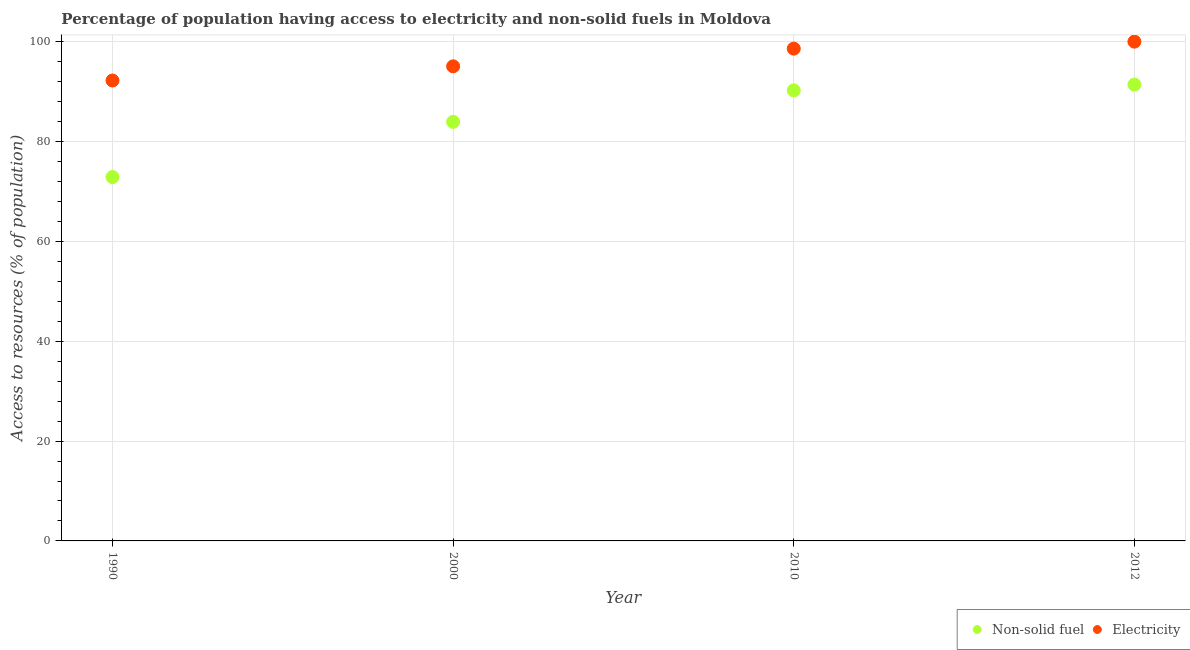How many different coloured dotlines are there?
Ensure brevity in your answer.  2. What is the percentage of population having access to electricity in 2010?
Make the answer very short. 98.6. Across all years, what is the maximum percentage of population having access to non-solid fuel?
Your answer should be very brief. 91.4. Across all years, what is the minimum percentage of population having access to electricity?
Your answer should be compact. 92.22. In which year was the percentage of population having access to non-solid fuel minimum?
Ensure brevity in your answer.  1990. What is the total percentage of population having access to electricity in the graph?
Your answer should be compact. 385.87. What is the difference between the percentage of population having access to electricity in 1990 and that in 2000?
Your answer should be compact. -2.84. What is the difference between the percentage of population having access to electricity in 2012 and the percentage of population having access to non-solid fuel in 2000?
Ensure brevity in your answer.  16.07. What is the average percentage of population having access to electricity per year?
Your answer should be very brief. 96.47. In the year 2012, what is the difference between the percentage of population having access to non-solid fuel and percentage of population having access to electricity?
Make the answer very short. -8.6. In how many years, is the percentage of population having access to electricity greater than 36 %?
Offer a terse response. 4. What is the ratio of the percentage of population having access to non-solid fuel in 1990 to that in 2010?
Offer a terse response. 0.81. Is the percentage of population having access to electricity in 2000 less than that in 2010?
Keep it short and to the point. Yes. What is the difference between the highest and the second highest percentage of population having access to electricity?
Your answer should be compact. 1.4. What is the difference between the highest and the lowest percentage of population having access to electricity?
Ensure brevity in your answer.  7.78. Is the sum of the percentage of population having access to electricity in 1990 and 2010 greater than the maximum percentage of population having access to non-solid fuel across all years?
Your answer should be very brief. Yes. Does the percentage of population having access to non-solid fuel monotonically increase over the years?
Give a very brief answer. Yes. Is the percentage of population having access to non-solid fuel strictly greater than the percentage of population having access to electricity over the years?
Provide a short and direct response. No. How many dotlines are there?
Provide a succinct answer. 2. How many years are there in the graph?
Make the answer very short. 4. Are the values on the major ticks of Y-axis written in scientific E-notation?
Make the answer very short. No. Where does the legend appear in the graph?
Offer a terse response. Bottom right. How many legend labels are there?
Offer a terse response. 2. What is the title of the graph?
Provide a short and direct response. Percentage of population having access to electricity and non-solid fuels in Moldova. What is the label or title of the X-axis?
Offer a terse response. Year. What is the label or title of the Y-axis?
Provide a succinct answer. Access to resources (% of population). What is the Access to resources (% of population) in Non-solid fuel in 1990?
Make the answer very short. 72.88. What is the Access to resources (% of population) of Electricity in 1990?
Provide a short and direct response. 92.22. What is the Access to resources (% of population) of Non-solid fuel in 2000?
Offer a very short reply. 83.93. What is the Access to resources (% of population) of Electricity in 2000?
Your answer should be compact. 95.06. What is the Access to resources (% of population) in Non-solid fuel in 2010?
Keep it short and to the point. 90.24. What is the Access to resources (% of population) of Electricity in 2010?
Give a very brief answer. 98.6. What is the Access to resources (% of population) in Non-solid fuel in 2012?
Your answer should be compact. 91.4. Across all years, what is the maximum Access to resources (% of population) in Non-solid fuel?
Ensure brevity in your answer.  91.4. Across all years, what is the maximum Access to resources (% of population) of Electricity?
Offer a terse response. 100. Across all years, what is the minimum Access to resources (% of population) in Non-solid fuel?
Ensure brevity in your answer.  72.88. Across all years, what is the minimum Access to resources (% of population) of Electricity?
Ensure brevity in your answer.  92.22. What is the total Access to resources (% of population) of Non-solid fuel in the graph?
Keep it short and to the point. 338.45. What is the total Access to resources (% of population) of Electricity in the graph?
Make the answer very short. 385.87. What is the difference between the Access to resources (% of population) of Non-solid fuel in 1990 and that in 2000?
Give a very brief answer. -11.05. What is the difference between the Access to resources (% of population) in Electricity in 1990 and that in 2000?
Offer a terse response. -2.84. What is the difference between the Access to resources (% of population) of Non-solid fuel in 1990 and that in 2010?
Make the answer very short. -17.36. What is the difference between the Access to resources (% of population) in Electricity in 1990 and that in 2010?
Offer a very short reply. -6.38. What is the difference between the Access to resources (% of population) of Non-solid fuel in 1990 and that in 2012?
Provide a short and direct response. -18.52. What is the difference between the Access to resources (% of population) in Electricity in 1990 and that in 2012?
Provide a short and direct response. -7.78. What is the difference between the Access to resources (% of population) in Non-solid fuel in 2000 and that in 2010?
Your answer should be very brief. -6.31. What is the difference between the Access to resources (% of population) in Electricity in 2000 and that in 2010?
Provide a succinct answer. -3.54. What is the difference between the Access to resources (% of population) of Non-solid fuel in 2000 and that in 2012?
Offer a very short reply. -7.46. What is the difference between the Access to resources (% of population) in Electricity in 2000 and that in 2012?
Provide a succinct answer. -4.94. What is the difference between the Access to resources (% of population) in Non-solid fuel in 2010 and that in 2012?
Provide a short and direct response. -1.15. What is the difference between the Access to resources (% of population) of Electricity in 2010 and that in 2012?
Keep it short and to the point. -1.4. What is the difference between the Access to resources (% of population) of Non-solid fuel in 1990 and the Access to resources (% of population) of Electricity in 2000?
Your answer should be very brief. -22.18. What is the difference between the Access to resources (% of population) of Non-solid fuel in 1990 and the Access to resources (% of population) of Electricity in 2010?
Offer a terse response. -25.72. What is the difference between the Access to resources (% of population) in Non-solid fuel in 1990 and the Access to resources (% of population) in Electricity in 2012?
Give a very brief answer. -27.12. What is the difference between the Access to resources (% of population) in Non-solid fuel in 2000 and the Access to resources (% of population) in Electricity in 2010?
Ensure brevity in your answer.  -14.67. What is the difference between the Access to resources (% of population) of Non-solid fuel in 2000 and the Access to resources (% of population) of Electricity in 2012?
Keep it short and to the point. -16.07. What is the difference between the Access to resources (% of population) in Non-solid fuel in 2010 and the Access to resources (% of population) in Electricity in 2012?
Your answer should be compact. -9.76. What is the average Access to resources (% of population) in Non-solid fuel per year?
Your answer should be very brief. 84.61. What is the average Access to resources (% of population) in Electricity per year?
Keep it short and to the point. 96.47. In the year 1990, what is the difference between the Access to resources (% of population) of Non-solid fuel and Access to resources (% of population) of Electricity?
Give a very brief answer. -19.34. In the year 2000, what is the difference between the Access to resources (% of population) in Non-solid fuel and Access to resources (% of population) in Electricity?
Give a very brief answer. -11.12. In the year 2010, what is the difference between the Access to resources (% of population) of Non-solid fuel and Access to resources (% of population) of Electricity?
Ensure brevity in your answer.  -8.36. In the year 2012, what is the difference between the Access to resources (% of population) of Non-solid fuel and Access to resources (% of population) of Electricity?
Make the answer very short. -8.6. What is the ratio of the Access to resources (% of population) of Non-solid fuel in 1990 to that in 2000?
Provide a succinct answer. 0.87. What is the ratio of the Access to resources (% of population) of Electricity in 1990 to that in 2000?
Offer a terse response. 0.97. What is the ratio of the Access to resources (% of population) in Non-solid fuel in 1990 to that in 2010?
Your answer should be very brief. 0.81. What is the ratio of the Access to resources (% of population) of Electricity in 1990 to that in 2010?
Provide a succinct answer. 0.94. What is the ratio of the Access to resources (% of population) in Non-solid fuel in 1990 to that in 2012?
Your response must be concise. 0.8. What is the ratio of the Access to resources (% of population) of Electricity in 1990 to that in 2012?
Your response must be concise. 0.92. What is the ratio of the Access to resources (% of population) of Non-solid fuel in 2000 to that in 2010?
Ensure brevity in your answer.  0.93. What is the ratio of the Access to resources (% of population) of Electricity in 2000 to that in 2010?
Offer a very short reply. 0.96. What is the ratio of the Access to resources (% of population) in Non-solid fuel in 2000 to that in 2012?
Provide a short and direct response. 0.92. What is the ratio of the Access to resources (% of population) of Electricity in 2000 to that in 2012?
Provide a succinct answer. 0.95. What is the ratio of the Access to resources (% of population) in Non-solid fuel in 2010 to that in 2012?
Provide a succinct answer. 0.99. What is the ratio of the Access to resources (% of population) of Electricity in 2010 to that in 2012?
Give a very brief answer. 0.99. What is the difference between the highest and the second highest Access to resources (% of population) in Non-solid fuel?
Your answer should be very brief. 1.15. What is the difference between the highest and the second highest Access to resources (% of population) in Electricity?
Make the answer very short. 1.4. What is the difference between the highest and the lowest Access to resources (% of population) in Non-solid fuel?
Your response must be concise. 18.52. What is the difference between the highest and the lowest Access to resources (% of population) of Electricity?
Provide a short and direct response. 7.78. 